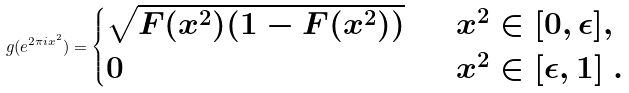<formula> <loc_0><loc_0><loc_500><loc_500>g ( e ^ { 2 \pi i x ^ { 2 } } ) = \begin{cases} \sqrt { F ( x ^ { 2 } ) ( 1 - F ( x ^ { 2 } ) ) } & \ \ x ^ { 2 } \in [ 0 , \epsilon ] , \\ 0 & \ \ x ^ { 2 } \in [ \epsilon , 1 ] \ . \end{cases}</formula> 